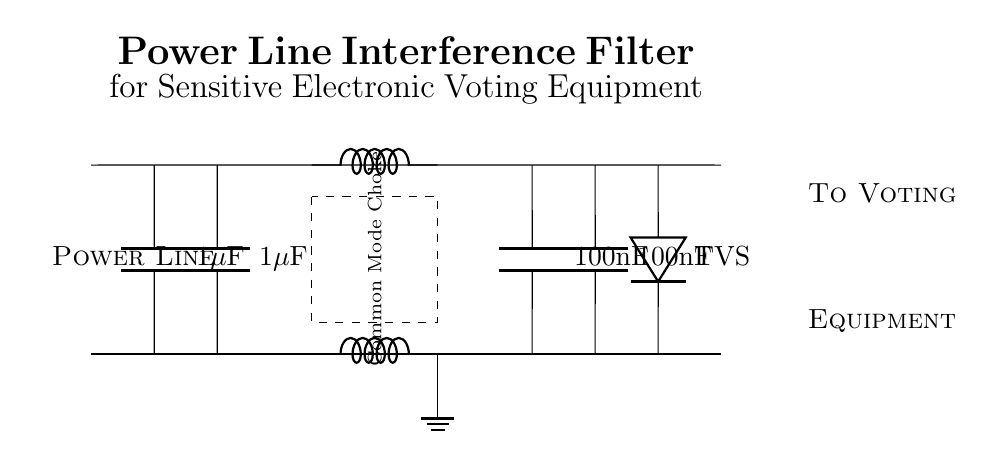What is the total capacitance of the input capacitors? There are two input capacitors, each with a capacitance of 1 microfarad. When capacitors are connected in parallel, their capacitances add up. Therefore, the total capacitance is 1 microfarad plus 1 microfarad, which equals 2 microfarads.
Answer: 2 microfarads What is the purpose of the common mode choke? The common mode choke is designed to suppress common mode noise signals that can interfere with the sensitive electronic voting equipment. It operates by allowing differential signals to pass while blocking or reducing unwanted noise, effectively improving signal integrity.
Answer: Suppress noise How many output capacitors are there in the circuit? There are two output capacitors in the circuit, each labeled as having a capacitance of 100 nanofarads. The presence of both capacitors serves the function of filtering out high-frequency noise from the power supply before reaching the voting equipment.
Answer: 2 What is the function of the transient voltage suppressor? The transient voltage suppressor protects the sensitive voting equipment from voltage spikes and surges that can lead to damage. It clamps down excess voltage, allowing the equipment to operate safely under varying power conditions.
Answer: Protect equipment What capacitance value is indicated for each output capacitor? Each output capacitor in the circuit is labeled with a capacitance of 100 nanofarads. This specific capacitance is suitable for filtering applications, particularly in reducing high-frequency noise that may affect the operation of the electronic components in the voting equipment.
Answer: 100 nanofarads What type of circuit is this diagram illustrating? This circuit is an interference filter specifically designed for electronic voting equipment. It's intended to eliminate power line noise that could affect the clarity and reliability of the signals used by the voting devices, ensuring their proper function during operation.
Answer: Interference filter 